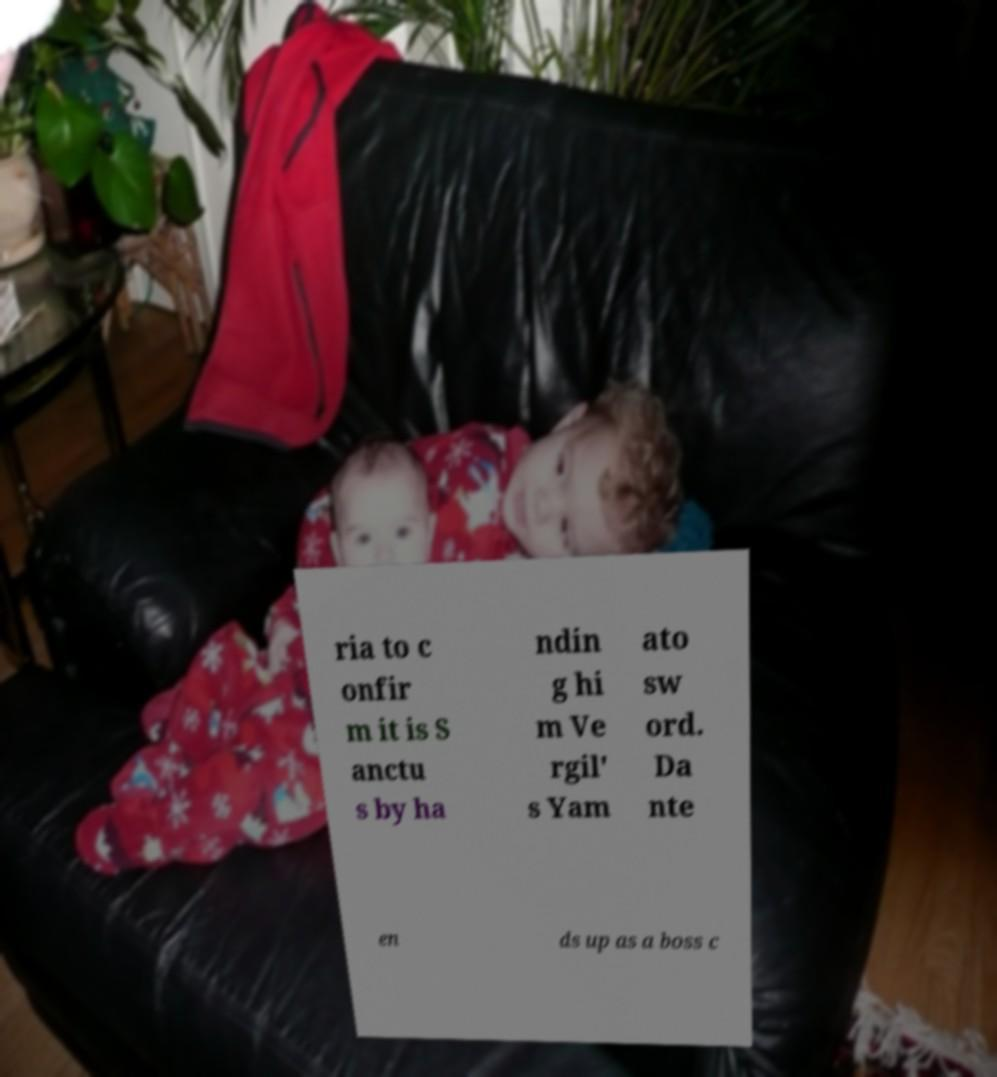Can you accurately transcribe the text from the provided image for me? ria to c onfir m it is S anctu s by ha ndin g hi m Ve rgil' s Yam ato sw ord. Da nte en ds up as a boss c 